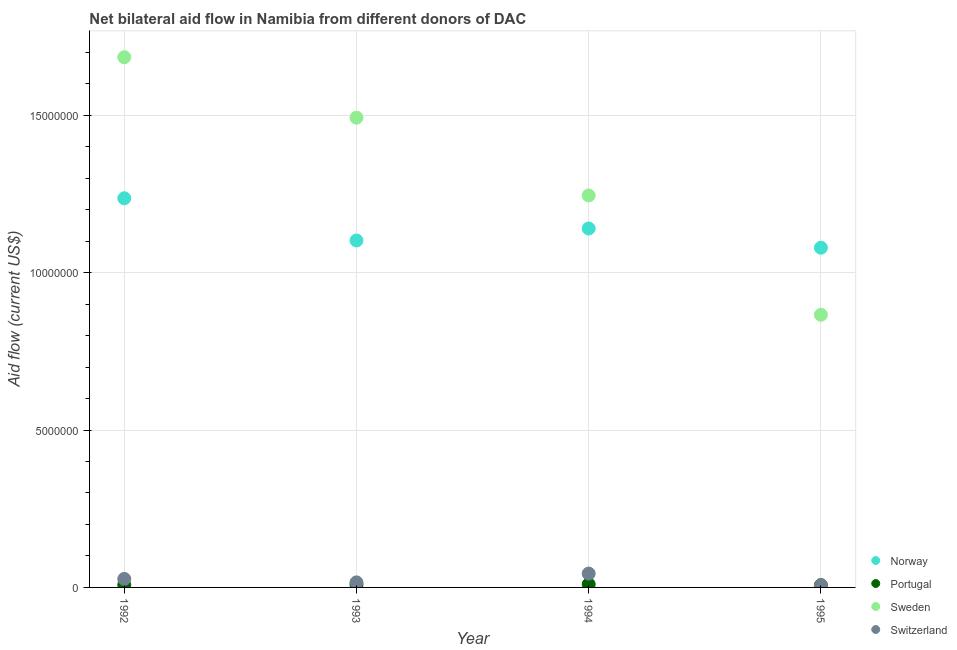How many different coloured dotlines are there?
Keep it short and to the point. 4. What is the amount of aid given by norway in 1994?
Provide a short and direct response. 1.14e+07. Across all years, what is the maximum amount of aid given by sweden?
Keep it short and to the point. 1.68e+07. Across all years, what is the minimum amount of aid given by sweden?
Your answer should be very brief. 8.66e+06. In which year was the amount of aid given by sweden maximum?
Your response must be concise. 1992. In which year was the amount of aid given by switzerland minimum?
Give a very brief answer. 1995. What is the total amount of aid given by portugal in the graph?
Ensure brevity in your answer.  3.40e+05. What is the difference between the amount of aid given by portugal in 1993 and that in 1994?
Give a very brief answer. -10000. What is the difference between the amount of aid given by norway in 1994 and the amount of aid given by sweden in 1993?
Keep it short and to the point. -3.52e+06. What is the average amount of aid given by sweden per year?
Offer a very short reply. 1.32e+07. In the year 1993, what is the difference between the amount of aid given by sweden and amount of aid given by switzerland?
Keep it short and to the point. 1.48e+07. What is the ratio of the amount of aid given by switzerland in 1993 to that in 1995?
Offer a terse response. 2.29. What is the difference between the highest and the lowest amount of aid given by sweden?
Give a very brief answer. 8.18e+06. In how many years, is the amount of aid given by switzerland greater than the average amount of aid given by switzerland taken over all years?
Ensure brevity in your answer.  2. Is the sum of the amount of aid given by switzerland in 1993 and 1994 greater than the maximum amount of aid given by portugal across all years?
Your answer should be very brief. Yes. How many years are there in the graph?
Make the answer very short. 4. How many legend labels are there?
Your answer should be very brief. 4. What is the title of the graph?
Offer a terse response. Net bilateral aid flow in Namibia from different donors of DAC. Does "Corruption" appear as one of the legend labels in the graph?
Provide a short and direct response. No. What is the label or title of the X-axis?
Provide a short and direct response. Year. What is the Aid flow (current US$) in Norway in 1992?
Your answer should be compact. 1.24e+07. What is the Aid flow (current US$) in Sweden in 1992?
Make the answer very short. 1.68e+07. What is the Aid flow (current US$) of Switzerland in 1992?
Give a very brief answer. 2.70e+05. What is the Aid flow (current US$) in Norway in 1993?
Your answer should be very brief. 1.10e+07. What is the Aid flow (current US$) in Portugal in 1993?
Keep it short and to the point. 9.00e+04. What is the Aid flow (current US$) in Sweden in 1993?
Make the answer very short. 1.49e+07. What is the Aid flow (current US$) of Norway in 1994?
Your answer should be compact. 1.14e+07. What is the Aid flow (current US$) of Sweden in 1994?
Provide a short and direct response. 1.24e+07. What is the Aid flow (current US$) in Norway in 1995?
Offer a terse response. 1.08e+07. What is the Aid flow (current US$) of Portugal in 1995?
Offer a very short reply. 7.00e+04. What is the Aid flow (current US$) in Sweden in 1995?
Your answer should be very brief. 8.66e+06. Across all years, what is the maximum Aid flow (current US$) of Norway?
Give a very brief answer. 1.24e+07. Across all years, what is the maximum Aid flow (current US$) of Portugal?
Provide a succinct answer. 1.00e+05. Across all years, what is the maximum Aid flow (current US$) in Sweden?
Make the answer very short. 1.68e+07. Across all years, what is the minimum Aid flow (current US$) in Norway?
Ensure brevity in your answer.  1.08e+07. Across all years, what is the minimum Aid flow (current US$) of Portugal?
Offer a very short reply. 7.00e+04. Across all years, what is the minimum Aid flow (current US$) of Sweden?
Ensure brevity in your answer.  8.66e+06. What is the total Aid flow (current US$) in Norway in the graph?
Your answer should be very brief. 4.56e+07. What is the total Aid flow (current US$) of Portugal in the graph?
Give a very brief answer. 3.40e+05. What is the total Aid flow (current US$) of Sweden in the graph?
Provide a succinct answer. 5.29e+07. What is the total Aid flow (current US$) in Switzerland in the graph?
Offer a terse response. 9.40e+05. What is the difference between the Aid flow (current US$) of Norway in 1992 and that in 1993?
Your answer should be compact. 1.34e+06. What is the difference between the Aid flow (current US$) of Portugal in 1992 and that in 1993?
Your answer should be very brief. -10000. What is the difference between the Aid flow (current US$) of Sweden in 1992 and that in 1993?
Ensure brevity in your answer.  1.92e+06. What is the difference between the Aid flow (current US$) of Switzerland in 1992 and that in 1993?
Provide a short and direct response. 1.10e+05. What is the difference between the Aid flow (current US$) in Norway in 1992 and that in 1994?
Your answer should be compact. 9.60e+05. What is the difference between the Aid flow (current US$) in Sweden in 1992 and that in 1994?
Your answer should be very brief. 4.39e+06. What is the difference between the Aid flow (current US$) in Switzerland in 1992 and that in 1994?
Ensure brevity in your answer.  -1.70e+05. What is the difference between the Aid flow (current US$) of Norway in 1992 and that in 1995?
Your answer should be compact. 1.57e+06. What is the difference between the Aid flow (current US$) in Portugal in 1992 and that in 1995?
Your answer should be very brief. 10000. What is the difference between the Aid flow (current US$) in Sweden in 1992 and that in 1995?
Keep it short and to the point. 8.18e+06. What is the difference between the Aid flow (current US$) of Norway in 1993 and that in 1994?
Your response must be concise. -3.80e+05. What is the difference between the Aid flow (current US$) of Portugal in 1993 and that in 1994?
Offer a terse response. -10000. What is the difference between the Aid flow (current US$) of Sweden in 1993 and that in 1994?
Provide a succinct answer. 2.47e+06. What is the difference between the Aid flow (current US$) in Switzerland in 1993 and that in 1994?
Offer a terse response. -2.80e+05. What is the difference between the Aid flow (current US$) in Norway in 1993 and that in 1995?
Keep it short and to the point. 2.30e+05. What is the difference between the Aid flow (current US$) of Sweden in 1993 and that in 1995?
Your response must be concise. 6.26e+06. What is the difference between the Aid flow (current US$) in Switzerland in 1993 and that in 1995?
Make the answer very short. 9.00e+04. What is the difference between the Aid flow (current US$) of Norway in 1994 and that in 1995?
Ensure brevity in your answer.  6.10e+05. What is the difference between the Aid flow (current US$) in Sweden in 1994 and that in 1995?
Your response must be concise. 3.79e+06. What is the difference between the Aid flow (current US$) of Switzerland in 1994 and that in 1995?
Give a very brief answer. 3.70e+05. What is the difference between the Aid flow (current US$) of Norway in 1992 and the Aid flow (current US$) of Portugal in 1993?
Provide a succinct answer. 1.23e+07. What is the difference between the Aid flow (current US$) in Norway in 1992 and the Aid flow (current US$) in Sweden in 1993?
Offer a terse response. -2.56e+06. What is the difference between the Aid flow (current US$) of Norway in 1992 and the Aid flow (current US$) of Switzerland in 1993?
Offer a very short reply. 1.22e+07. What is the difference between the Aid flow (current US$) in Portugal in 1992 and the Aid flow (current US$) in Sweden in 1993?
Offer a very short reply. -1.48e+07. What is the difference between the Aid flow (current US$) of Portugal in 1992 and the Aid flow (current US$) of Switzerland in 1993?
Your answer should be very brief. -8.00e+04. What is the difference between the Aid flow (current US$) in Sweden in 1992 and the Aid flow (current US$) in Switzerland in 1993?
Provide a short and direct response. 1.67e+07. What is the difference between the Aid flow (current US$) in Norway in 1992 and the Aid flow (current US$) in Portugal in 1994?
Offer a very short reply. 1.23e+07. What is the difference between the Aid flow (current US$) in Norway in 1992 and the Aid flow (current US$) in Sweden in 1994?
Provide a short and direct response. -9.00e+04. What is the difference between the Aid flow (current US$) of Norway in 1992 and the Aid flow (current US$) of Switzerland in 1994?
Provide a short and direct response. 1.19e+07. What is the difference between the Aid flow (current US$) in Portugal in 1992 and the Aid flow (current US$) in Sweden in 1994?
Ensure brevity in your answer.  -1.24e+07. What is the difference between the Aid flow (current US$) of Portugal in 1992 and the Aid flow (current US$) of Switzerland in 1994?
Provide a succinct answer. -3.60e+05. What is the difference between the Aid flow (current US$) in Sweden in 1992 and the Aid flow (current US$) in Switzerland in 1994?
Make the answer very short. 1.64e+07. What is the difference between the Aid flow (current US$) of Norway in 1992 and the Aid flow (current US$) of Portugal in 1995?
Keep it short and to the point. 1.23e+07. What is the difference between the Aid flow (current US$) in Norway in 1992 and the Aid flow (current US$) in Sweden in 1995?
Offer a terse response. 3.70e+06. What is the difference between the Aid flow (current US$) of Norway in 1992 and the Aid flow (current US$) of Switzerland in 1995?
Offer a very short reply. 1.23e+07. What is the difference between the Aid flow (current US$) of Portugal in 1992 and the Aid flow (current US$) of Sweden in 1995?
Provide a short and direct response. -8.58e+06. What is the difference between the Aid flow (current US$) in Sweden in 1992 and the Aid flow (current US$) in Switzerland in 1995?
Give a very brief answer. 1.68e+07. What is the difference between the Aid flow (current US$) in Norway in 1993 and the Aid flow (current US$) in Portugal in 1994?
Make the answer very short. 1.09e+07. What is the difference between the Aid flow (current US$) of Norway in 1993 and the Aid flow (current US$) of Sweden in 1994?
Your answer should be very brief. -1.43e+06. What is the difference between the Aid flow (current US$) of Norway in 1993 and the Aid flow (current US$) of Switzerland in 1994?
Your answer should be very brief. 1.06e+07. What is the difference between the Aid flow (current US$) in Portugal in 1993 and the Aid flow (current US$) in Sweden in 1994?
Provide a short and direct response. -1.24e+07. What is the difference between the Aid flow (current US$) of Portugal in 1993 and the Aid flow (current US$) of Switzerland in 1994?
Ensure brevity in your answer.  -3.50e+05. What is the difference between the Aid flow (current US$) in Sweden in 1993 and the Aid flow (current US$) in Switzerland in 1994?
Offer a terse response. 1.45e+07. What is the difference between the Aid flow (current US$) in Norway in 1993 and the Aid flow (current US$) in Portugal in 1995?
Provide a short and direct response. 1.10e+07. What is the difference between the Aid flow (current US$) in Norway in 1993 and the Aid flow (current US$) in Sweden in 1995?
Offer a terse response. 2.36e+06. What is the difference between the Aid flow (current US$) in Norway in 1993 and the Aid flow (current US$) in Switzerland in 1995?
Offer a very short reply. 1.10e+07. What is the difference between the Aid flow (current US$) of Portugal in 1993 and the Aid flow (current US$) of Sweden in 1995?
Give a very brief answer. -8.57e+06. What is the difference between the Aid flow (current US$) in Portugal in 1993 and the Aid flow (current US$) in Switzerland in 1995?
Your answer should be compact. 2.00e+04. What is the difference between the Aid flow (current US$) in Sweden in 1993 and the Aid flow (current US$) in Switzerland in 1995?
Ensure brevity in your answer.  1.48e+07. What is the difference between the Aid flow (current US$) in Norway in 1994 and the Aid flow (current US$) in Portugal in 1995?
Keep it short and to the point. 1.13e+07. What is the difference between the Aid flow (current US$) in Norway in 1994 and the Aid flow (current US$) in Sweden in 1995?
Your response must be concise. 2.74e+06. What is the difference between the Aid flow (current US$) of Norway in 1994 and the Aid flow (current US$) of Switzerland in 1995?
Your response must be concise. 1.13e+07. What is the difference between the Aid flow (current US$) of Portugal in 1994 and the Aid flow (current US$) of Sweden in 1995?
Your answer should be very brief. -8.56e+06. What is the difference between the Aid flow (current US$) in Portugal in 1994 and the Aid flow (current US$) in Switzerland in 1995?
Ensure brevity in your answer.  3.00e+04. What is the difference between the Aid flow (current US$) of Sweden in 1994 and the Aid flow (current US$) of Switzerland in 1995?
Provide a short and direct response. 1.24e+07. What is the average Aid flow (current US$) of Norway per year?
Give a very brief answer. 1.14e+07. What is the average Aid flow (current US$) of Portugal per year?
Your answer should be very brief. 8.50e+04. What is the average Aid flow (current US$) in Sweden per year?
Your answer should be compact. 1.32e+07. What is the average Aid flow (current US$) in Switzerland per year?
Provide a short and direct response. 2.35e+05. In the year 1992, what is the difference between the Aid flow (current US$) of Norway and Aid flow (current US$) of Portugal?
Your answer should be very brief. 1.23e+07. In the year 1992, what is the difference between the Aid flow (current US$) in Norway and Aid flow (current US$) in Sweden?
Provide a succinct answer. -4.48e+06. In the year 1992, what is the difference between the Aid flow (current US$) of Norway and Aid flow (current US$) of Switzerland?
Make the answer very short. 1.21e+07. In the year 1992, what is the difference between the Aid flow (current US$) of Portugal and Aid flow (current US$) of Sweden?
Offer a terse response. -1.68e+07. In the year 1992, what is the difference between the Aid flow (current US$) of Sweden and Aid flow (current US$) of Switzerland?
Provide a succinct answer. 1.66e+07. In the year 1993, what is the difference between the Aid flow (current US$) of Norway and Aid flow (current US$) of Portugal?
Give a very brief answer. 1.09e+07. In the year 1993, what is the difference between the Aid flow (current US$) in Norway and Aid flow (current US$) in Sweden?
Your answer should be very brief. -3.90e+06. In the year 1993, what is the difference between the Aid flow (current US$) of Norway and Aid flow (current US$) of Switzerland?
Make the answer very short. 1.09e+07. In the year 1993, what is the difference between the Aid flow (current US$) of Portugal and Aid flow (current US$) of Sweden?
Keep it short and to the point. -1.48e+07. In the year 1993, what is the difference between the Aid flow (current US$) in Sweden and Aid flow (current US$) in Switzerland?
Your response must be concise. 1.48e+07. In the year 1994, what is the difference between the Aid flow (current US$) of Norway and Aid flow (current US$) of Portugal?
Offer a very short reply. 1.13e+07. In the year 1994, what is the difference between the Aid flow (current US$) of Norway and Aid flow (current US$) of Sweden?
Your answer should be compact. -1.05e+06. In the year 1994, what is the difference between the Aid flow (current US$) in Norway and Aid flow (current US$) in Switzerland?
Your response must be concise. 1.10e+07. In the year 1994, what is the difference between the Aid flow (current US$) in Portugal and Aid flow (current US$) in Sweden?
Keep it short and to the point. -1.24e+07. In the year 1994, what is the difference between the Aid flow (current US$) of Portugal and Aid flow (current US$) of Switzerland?
Keep it short and to the point. -3.40e+05. In the year 1994, what is the difference between the Aid flow (current US$) in Sweden and Aid flow (current US$) in Switzerland?
Ensure brevity in your answer.  1.20e+07. In the year 1995, what is the difference between the Aid flow (current US$) of Norway and Aid flow (current US$) of Portugal?
Provide a succinct answer. 1.07e+07. In the year 1995, what is the difference between the Aid flow (current US$) in Norway and Aid flow (current US$) in Sweden?
Your response must be concise. 2.13e+06. In the year 1995, what is the difference between the Aid flow (current US$) of Norway and Aid flow (current US$) of Switzerland?
Offer a very short reply. 1.07e+07. In the year 1995, what is the difference between the Aid flow (current US$) in Portugal and Aid flow (current US$) in Sweden?
Ensure brevity in your answer.  -8.59e+06. In the year 1995, what is the difference between the Aid flow (current US$) of Portugal and Aid flow (current US$) of Switzerland?
Offer a terse response. 0. In the year 1995, what is the difference between the Aid flow (current US$) of Sweden and Aid flow (current US$) of Switzerland?
Keep it short and to the point. 8.59e+06. What is the ratio of the Aid flow (current US$) of Norway in 1992 to that in 1993?
Provide a succinct answer. 1.12. What is the ratio of the Aid flow (current US$) of Sweden in 1992 to that in 1993?
Make the answer very short. 1.13. What is the ratio of the Aid flow (current US$) in Switzerland in 1992 to that in 1993?
Give a very brief answer. 1.69. What is the ratio of the Aid flow (current US$) of Norway in 1992 to that in 1994?
Offer a very short reply. 1.08. What is the ratio of the Aid flow (current US$) in Portugal in 1992 to that in 1994?
Your response must be concise. 0.8. What is the ratio of the Aid flow (current US$) of Sweden in 1992 to that in 1994?
Your answer should be very brief. 1.35. What is the ratio of the Aid flow (current US$) of Switzerland in 1992 to that in 1994?
Ensure brevity in your answer.  0.61. What is the ratio of the Aid flow (current US$) in Norway in 1992 to that in 1995?
Your answer should be compact. 1.15. What is the ratio of the Aid flow (current US$) in Sweden in 1992 to that in 1995?
Your answer should be very brief. 1.94. What is the ratio of the Aid flow (current US$) of Switzerland in 1992 to that in 1995?
Give a very brief answer. 3.86. What is the ratio of the Aid flow (current US$) in Norway in 1993 to that in 1994?
Make the answer very short. 0.97. What is the ratio of the Aid flow (current US$) of Sweden in 1993 to that in 1994?
Make the answer very short. 1.2. What is the ratio of the Aid flow (current US$) in Switzerland in 1993 to that in 1994?
Offer a very short reply. 0.36. What is the ratio of the Aid flow (current US$) in Norway in 1993 to that in 1995?
Keep it short and to the point. 1.02. What is the ratio of the Aid flow (current US$) in Sweden in 1993 to that in 1995?
Make the answer very short. 1.72. What is the ratio of the Aid flow (current US$) in Switzerland in 1993 to that in 1995?
Offer a terse response. 2.29. What is the ratio of the Aid flow (current US$) in Norway in 1994 to that in 1995?
Provide a succinct answer. 1.06. What is the ratio of the Aid flow (current US$) in Portugal in 1994 to that in 1995?
Make the answer very short. 1.43. What is the ratio of the Aid flow (current US$) in Sweden in 1994 to that in 1995?
Provide a short and direct response. 1.44. What is the ratio of the Aid flow (current US$) of Switzerland in 1994 to that in 1995?
Make the answer very short. 6.29. What is the difference between the highest and the second highest Aid flow (current US$) in Norway?
Provide a short and direct response. 9.60e+05. What is the difference between the highest and the second highest Aid flow (current US$) of Portugal?
Offer a terse response. 10000. What is the difference between the highest and the second highest Aid flow (current US$) in Sweden?
Provide a succinct answer. 1.92e+06. What is the difference between the highest and the lowest Aid flow (current US$) of Norway?
Your response must be concise. 1.57e+06. What is the difference between the highest and the lowest Aid flow (current US$) in Sweden?
Your answer should be compact. 8.18e+06. What is the difference between the highest and the lowest Aid flow (current US$) of Switzerland?
Ensure brevity in your answer.  3.70e+05. 